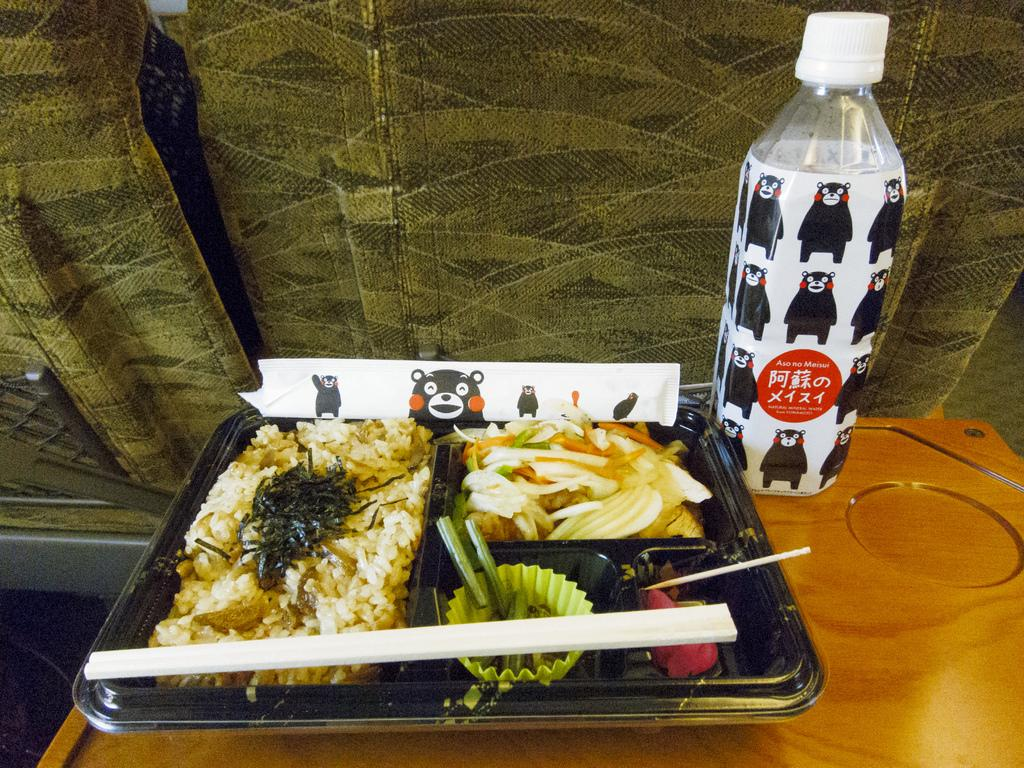What is on the plate that is visible in the image? There are food items on the plate in the image. What utensil is visible in the image? There is a chopstick in the image. Where is the plate located in the image? The plate is on a table in the image. What else can be seen on the table in the image? There is a water bottle on the table in the image. What type of toad is sitting on the plate in the image? There is no toad present on the plate or in the image. 